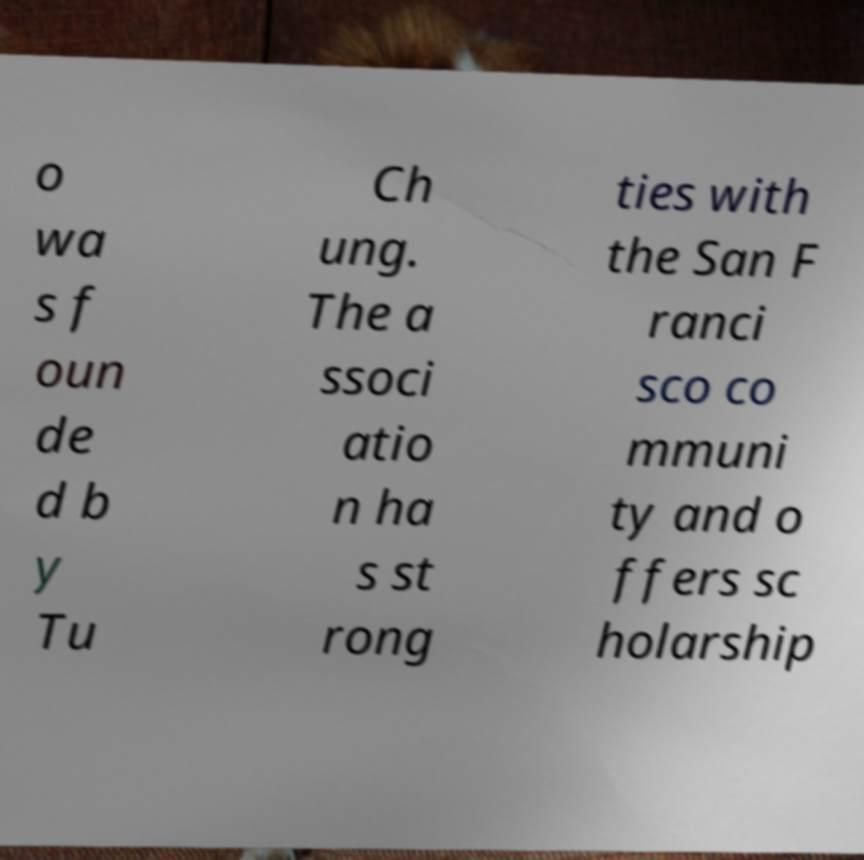Can you read and provide the text displayed in the image?This photo seems to have some interesting text. Can you extract and type it out for me? o wa s f oun de d b y Tu Ch ung. The a ssoci atio n ha s st rong ties with the San F ranci sco co mmuni ty and o ffers sc holarship 